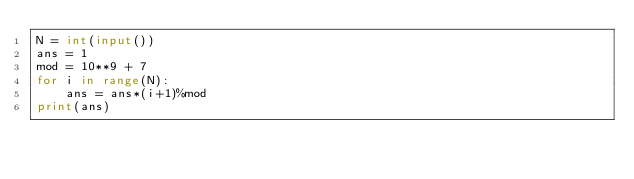Convert code to text. <code><loc_0><loc_0><loc_500><loc_500><_Python_>N = int(input())
ans = 1
mod = 10**9 + 7
for i in range(N):
	ans = ans*(i+1)%mod
print(ans)</code> 